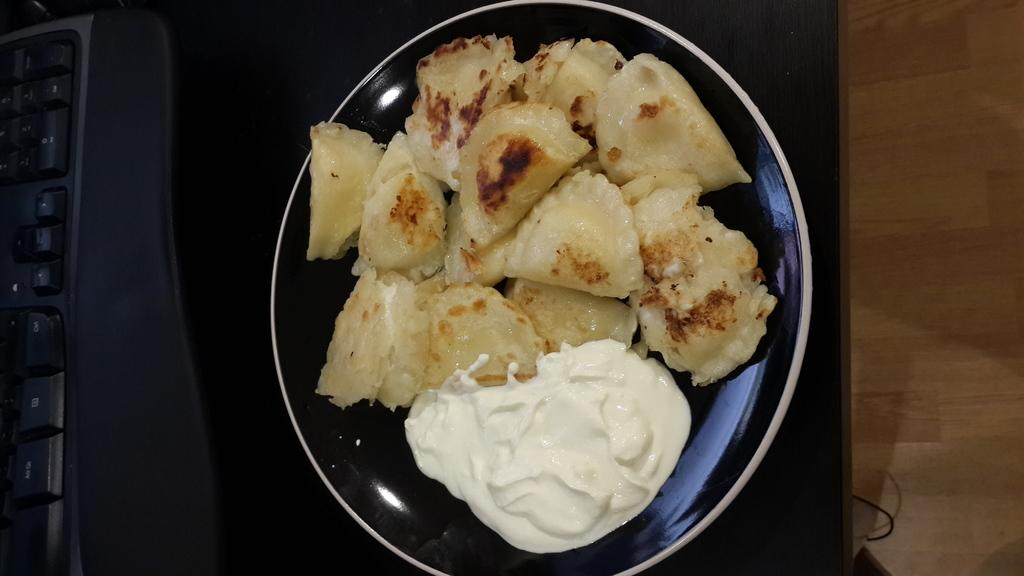What is the main subject of the image? There is a food item in the image. How is the food item presented? The food item is on a plate. What can be seen on the left side of the image? There is a keyboard on the left side of the image. What type of furniture is present in the image? There is a wooden table in the image. What type of flowers are arranged on the brick wall in the image? There is no brick wall or flowers present in the image. 